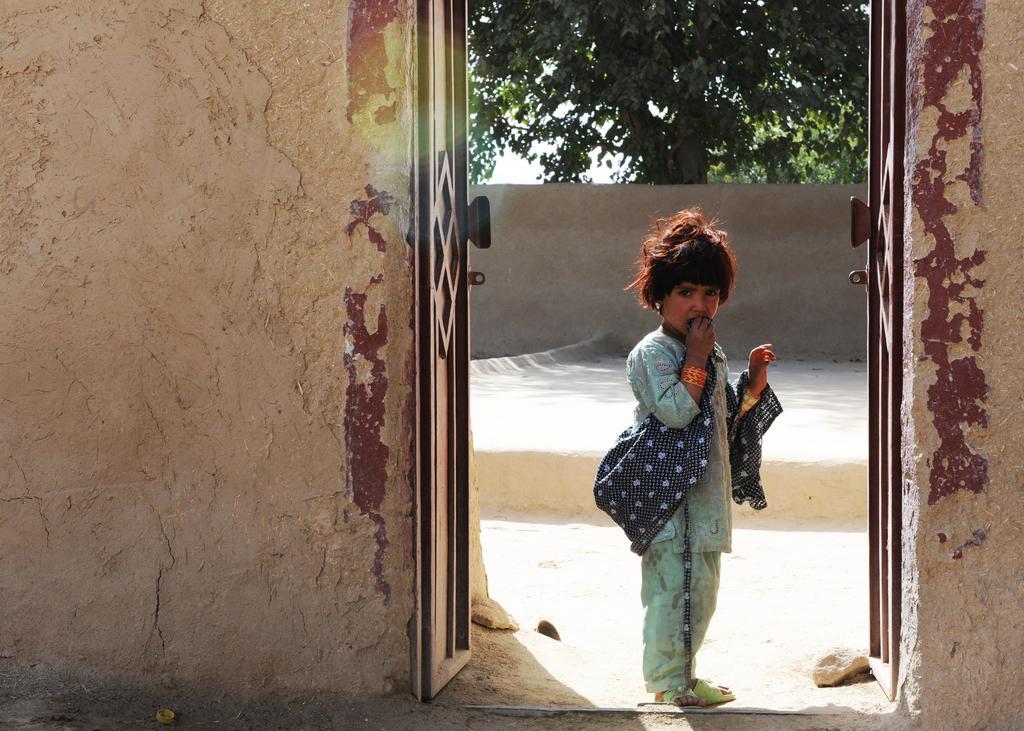Please provide a concise description of this image. In this image we can see a child standing on the ground. We can also see a door, the walls, some trees and the sky. 